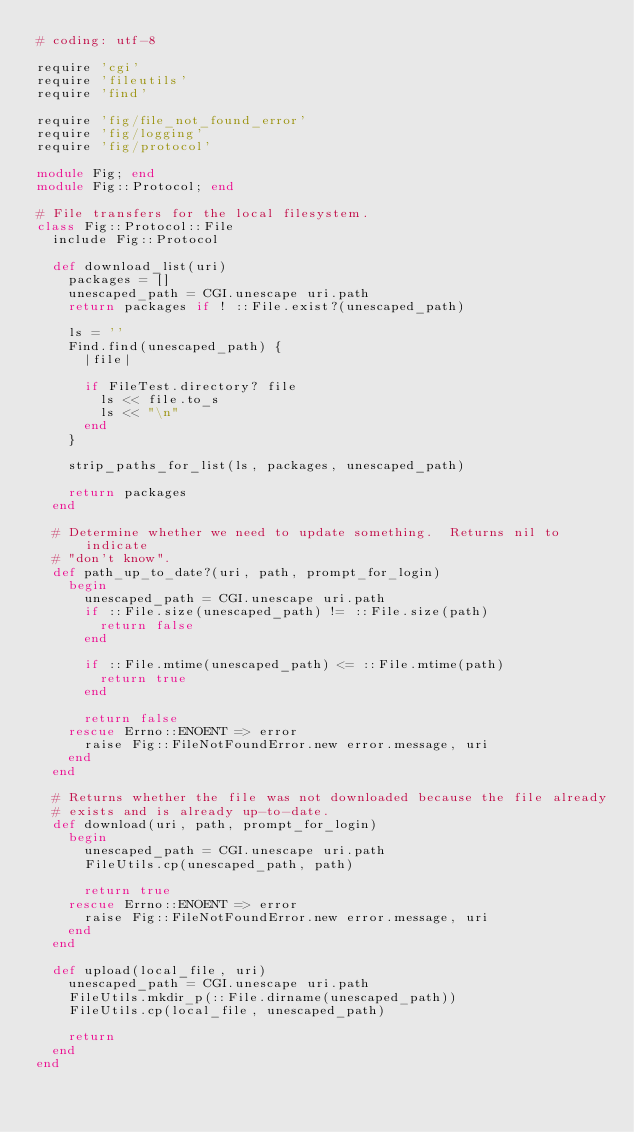Convert code to text. <code><loc_0><loc_0><loc_500><loc_500><_Ruby_># coding: utf-8

require 'cgi'
require 'fileutils'
require 'find'

require 'fig/file_not_found_error'
require 'fig/logging'
require 'fig/protocol'

module Fig; end
module Fig::Protocol; end

# File transfers for the local filesystem.
class Fig::Protocol::File
  include Fig::Protocol

  def download_list(uri)
    packages = []
    unescaped_path = CGI.unescape uri.path
    return packages if ! ::File.exist?(unescaped_path)

    ls = ''
    Find.find(unescaped_path) {
      |file|

      if FileTest.directory? file
        ls << file.to_s
        ls << "\n"
      end
    }

    strip_paths_for_list(ls, packages, unescaped_path)

    return packages
  end

  # Determine whether we need to update something.  Returns nil to indicate
  # "don't know".
  def path_up_to_date?(uri, path, prompt_for_login)
    begin
      unescaped_path = CGI.unescape uri.path
      if ::File.size(unescaped_path) != ::File.size(path)
        return false
      end

      if ::File.mtime(unescaped_path) <= ::File.mtime(path)
        return true
      end

      return false
    rescue Errno::ENOENT => error
      raise Fig::FileNotFoundError.new error.message, uri
    end
  end

  # Returns whether the file was not downloaded because the file already
  # exists and is already up-to-date.
  def download(uri, path, prompt_for_login)
    begin
      unescaped_path = CGI.unescape uri.path
      FileUtils.cp(unescaped_path, path)

      return true
    rescue Errno::ENOENT => error
      raise Fig::FileNotFoundError.new error.message, uri
    end
  end

  def upload(local_file, uri)
    unescaped_path = CGI.unescape uri.path
    FileUtils.mkdir_p(::File.dirname(unescaped_path))
    FileUtils.cp(local_file, unescaped_path)

    return
  end
end
</code> 